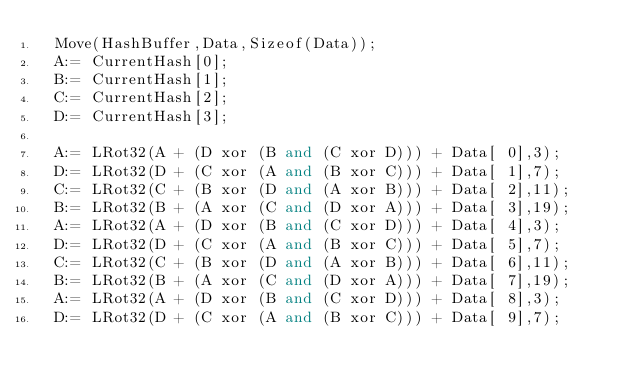<code> <loc_0><loc_0><loc_500><loc_500><_Pascal_>  Move(HashBuffer,Data,Sizeof(Data));
  A:= CurrentHash[0];
  B:= CurrentHash[1];
  C:= CurrentHash[2];
  D:= CurrentHash[3];

  A:= LRot32(A + (D xor (B and (C xor D))) + Data[ 0],3);
  D:= LRot32(D + (C xor (A and (B xor C))) + Data[ 1],7);
  C:= LRot32(C + (B xor (D and (A xor B))) + Data[ 2],11);
  B:= LRot32(B + (A xor (C and (D xor A))) + Data[ 3],19);
  A:= LRot32(A + (D xor (B and (C xor D))) + Data[ 4],3);
  D:= LRot32(D + (C xor (A and (B xor C))) + Data[ 5],7);
  C:= LRot32(C + (B xor (D and (A xor B))) + Data[ 6],11);
  B:= LRot32(B + (A xor (C and (D xor A))) + Data[ 7],19);
  A:= LRot32(A + (D xor (B and (C xor D))) + Data[ 8],3);
  D:= LRot32(D + (C xor (A and (B xor C))) + Data[ 9],7);</code> 